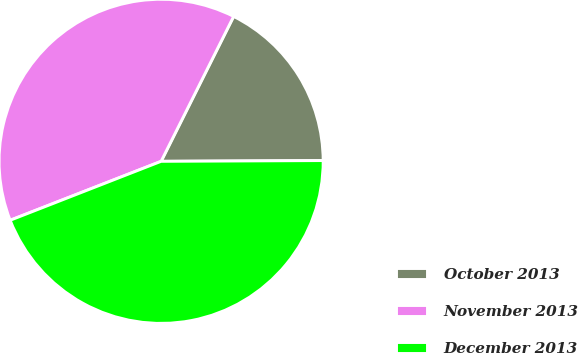Convert chart. <chart><loc_0><loc_0><loc_500><loc_500><pie_chart><fcel>October 2013<fcel>November 2013<fcel>December 2013<nl><fcel>17.54%<fcel>38.31%<fcel>44.15%<nl></chart> 